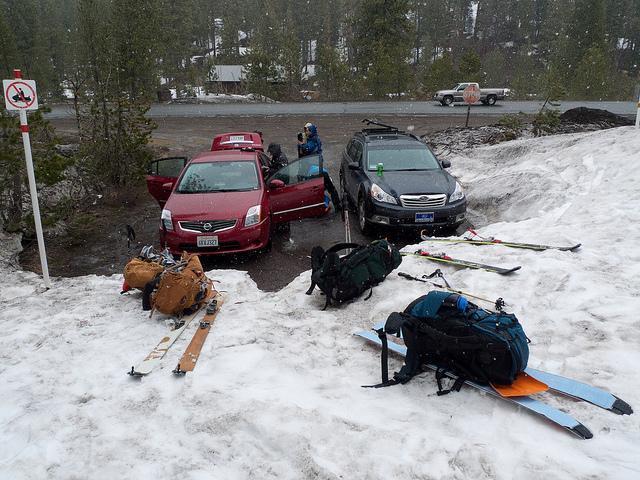How many cars are in this photo?
Give a very brief answer. 2. How many ski can you see?
Give a very brief answer. 2. How many cars are in the picture?
Give a very brief answer. 2. How many backpacks are in the photo?
Give a very brief answer. 3. 